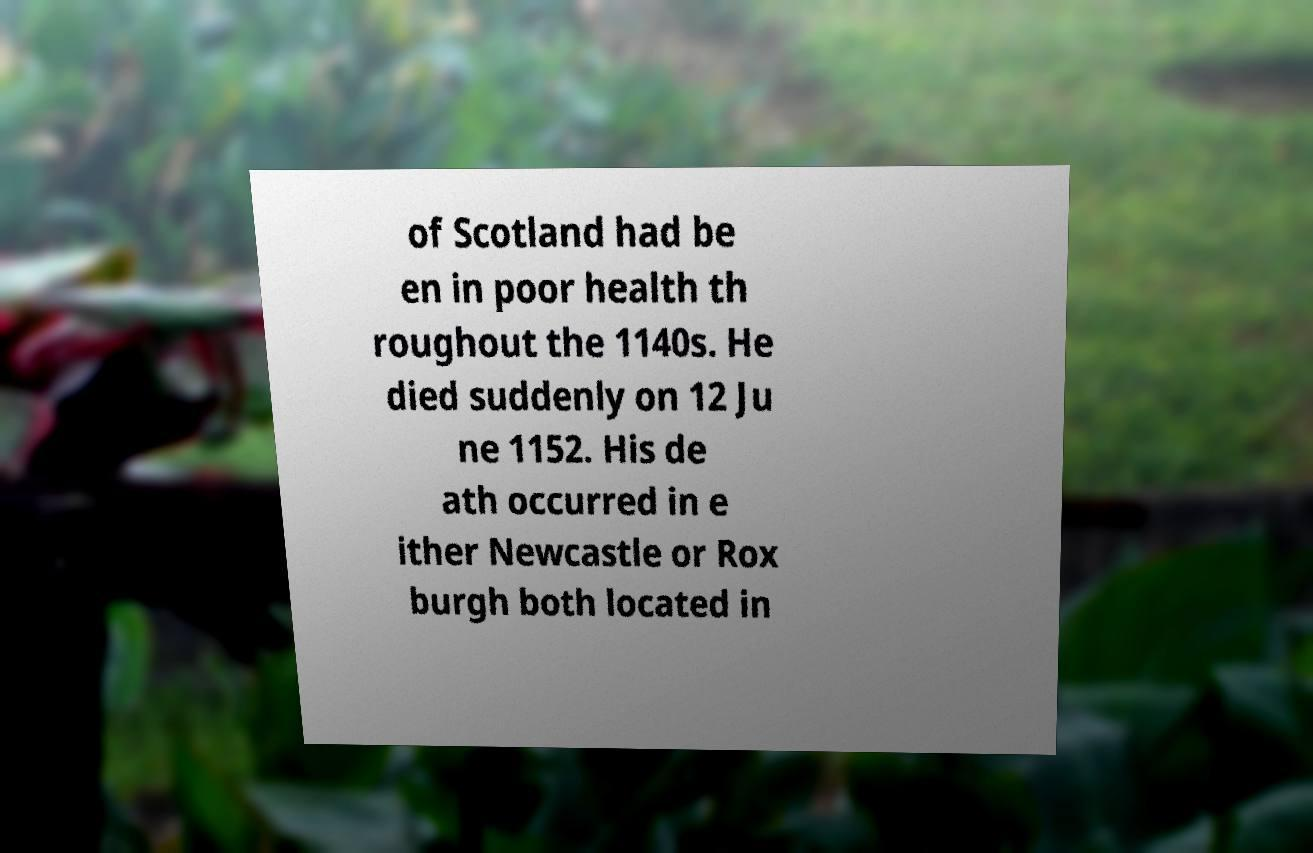Please identify and transcribe the text found in this image. of Scotland had be en in poor health th roughout the 1140s. He died suddenly on 12 Ju ne 1152. His de ath occurred in e ither Newcastle or Rox burgh both located in 